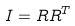Convert formula to latex. <formula><loc_0><loc_0><loc_500><loc_500>I = R R ^ { T }</formula> 